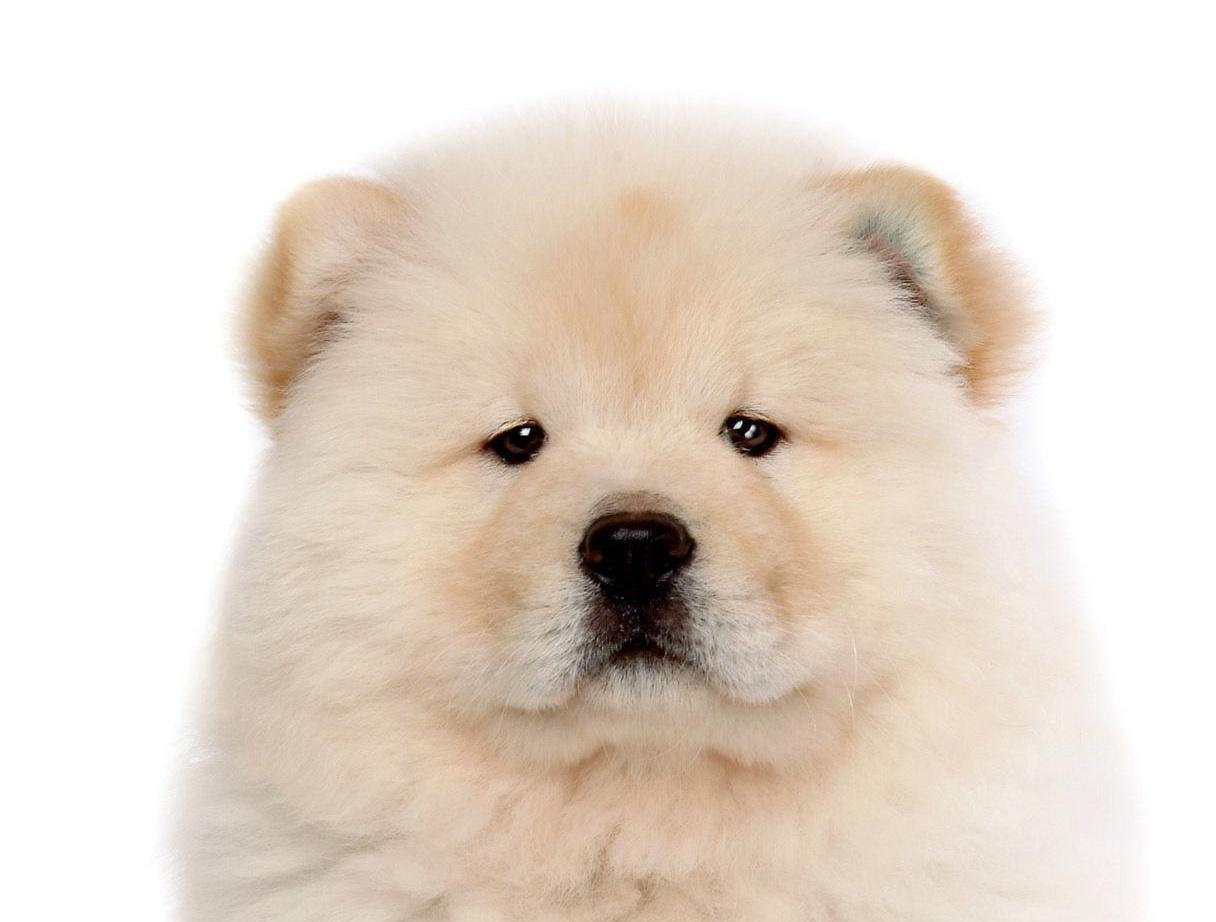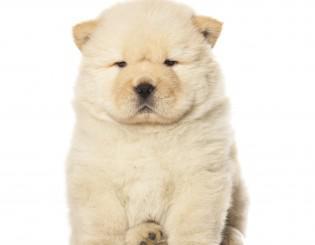The first image is the image on the left, the second image is the image on the right. Assess this claim about the two images: "The dogs in the two images look virtually identical.". Correct or not? Answer yes or no. Yes. 